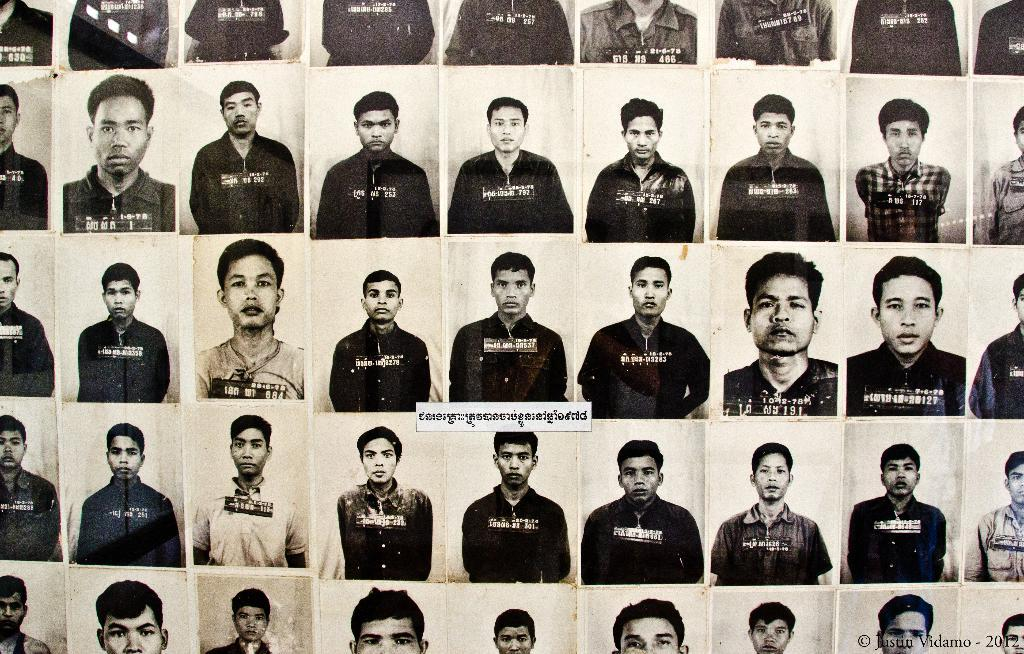What type of photos are present in the image? There are passport size photos of people in the image. Can you describe any additional features of the image? Yes, there is a watermark visible in the image. What type of hat is the person wearing in the image? There are no people visible in the image, only passport size photos, so it is not possible to determine if anyone is wearing a hat. 